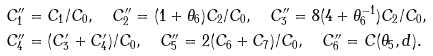<formula> <loc_0><loc_0><loc_500><loc_500>C ^ { \prime \prime } _ { 1 } & = C _ { 1 } / C _ { 0 } , \quad C ^ { \prime \prime } _ { 2 } = ( 1 + \theta _ { 6 } ) C _ { 2 } / C _ { 0 } , \quad C ^ { \prime \prime } _ { 3 } = 8 ( 4 + \theta _ { 6 } ^ { - 1 } ) C _ { 2 } / C _ { 0 } , \\ C ^ { \prime \prime } _ { 4 } & = ( C ^ { \prime } _ { 3 } + C ^ { \prime } _ { 4 } ) / C _ { 0 } , \quad C ^ { \prime \prime } _ { 5 } = 2 ( C _ { 6 } + C _ { 7 } ) / C _ { 0 } , \quad C ^ { \prime \prime } _ { 6 } = C ( \theta _ { 5 } , d ) .</formula> 